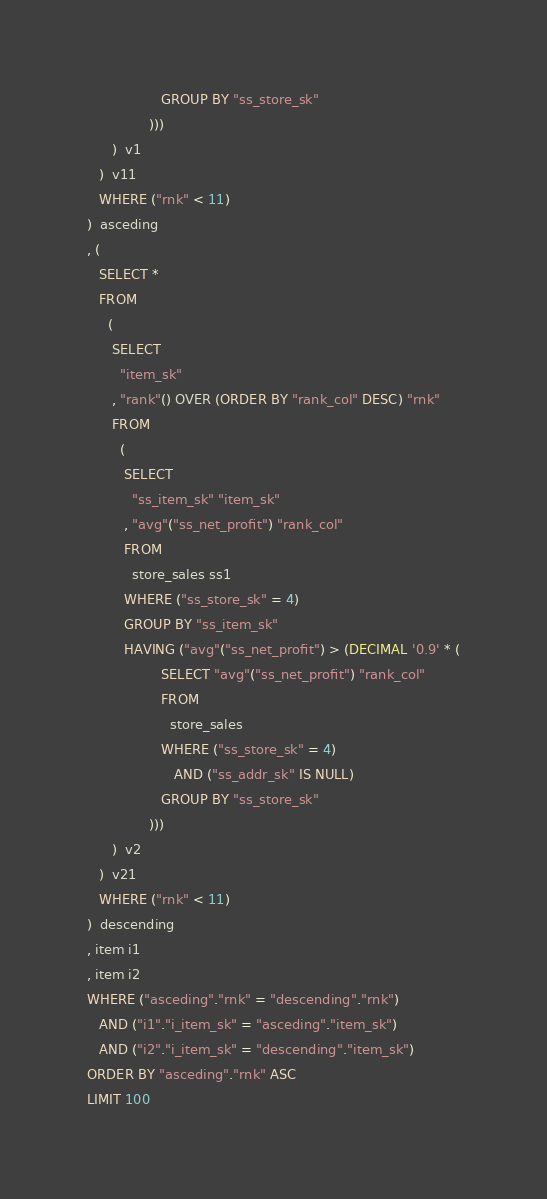Convert code to text. <code><loc_0><loc_0><loc_500><loc_500><_SQL_>                  GROUP BY "ss_store_sk"
               )))
      )  v1
   )  v11
   WHERE ("rnk" < 11)
)  asceding
, (
   SELECT *
   FROM
     (
      SELECT
        "item_sk"
      , "rank"() OVER (ORDER BY "rank_col" DESC) "rnk"
      FROM
        (
         SELECT
           "ss_item_sk" "item_sk"
         , "avg"("ss_net_profit") "rank_col"
         FROM
           store_sales ss1
         WHERE ("ss_store_sk" = 4)
         GROUP BY "ss_item_sk"
         HAVING ("avg"("ss_net_profit") > (DECIMAL '0.9' * (
                  SELECT "avg"("ss_net_profit") "rank_col"
                  FROM
                    store_sales
                  WHERE ("ss_store_sk" = 4)
                     AND ("ss_addr_sk" IS NULL)
                  GROUP BY "ss_store_sk"
               )))
      )  v2
   )  v21
   WHERE ("rnk" < 11)
)  descending
, item i1
, item i2
WHERE ("asceding"."rnk" = "descending"."rnk")
   AND ("i1"."i_item_sk" = "asceding"."item_sk")
   AND ("i2"."i_item_sk" = "descending"."item_sk")
ORDER BY "asceding"."rnk" ASC
LIMIT 100
</code> 